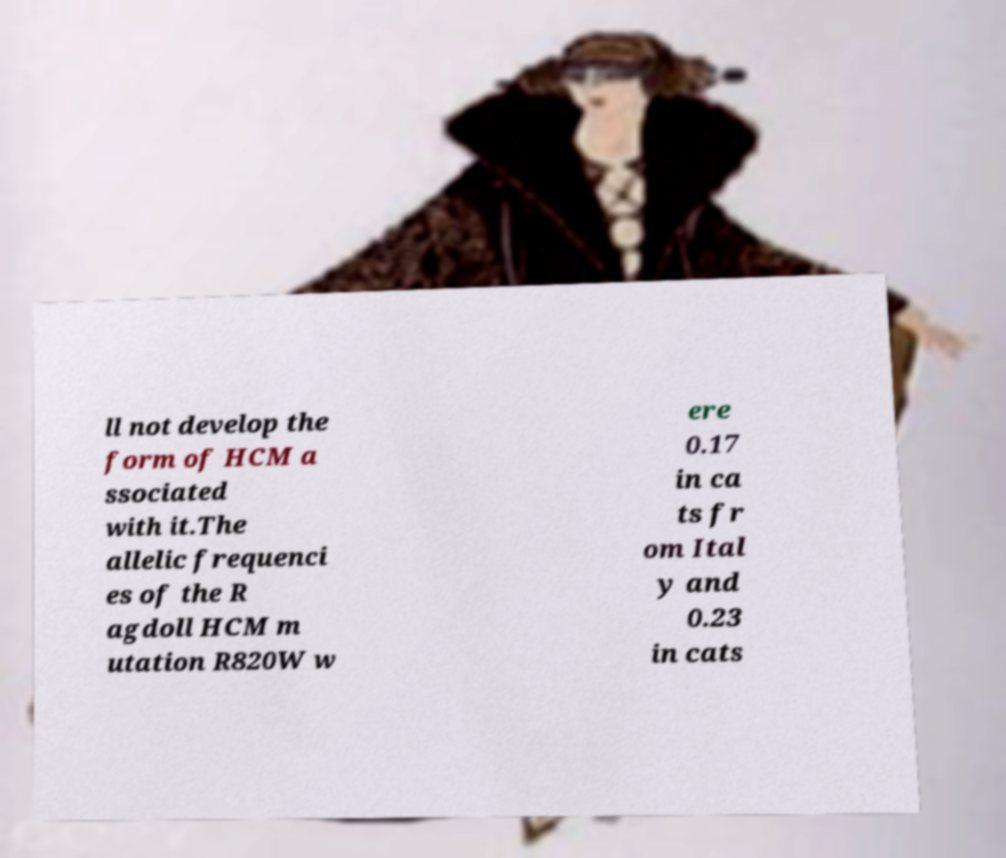For documentation purposes, I need the text within this image transcribed. Could you provide that? ll not develop the form of HCM a ssociated with it.The allelic frequenci es of the R agdoll HCM m utation R820W w ere 0.17 in ca ts fr om Ital y and 0.23 in cats 